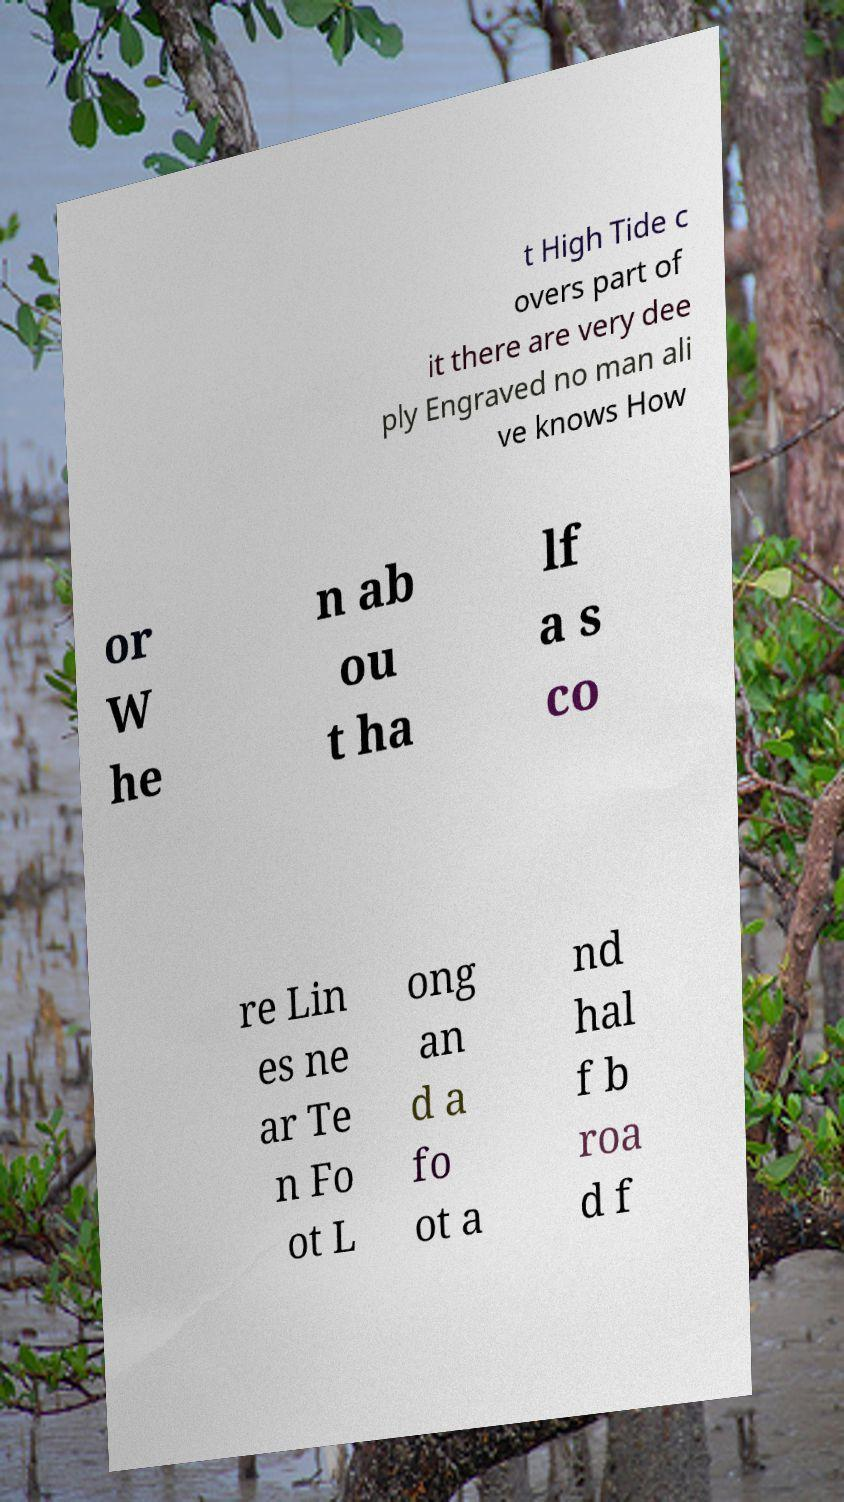For documentation purposes, I need the text within this image transcribed. Could you provide that? t High Tide c overs part of it there are very dee ply Engraved no man ali ve knows How or W he n ab ou t ha lf a s co re Lin es ne ar Te n Fo ot L ong an d a fo ot a nd hal f b roa d f 